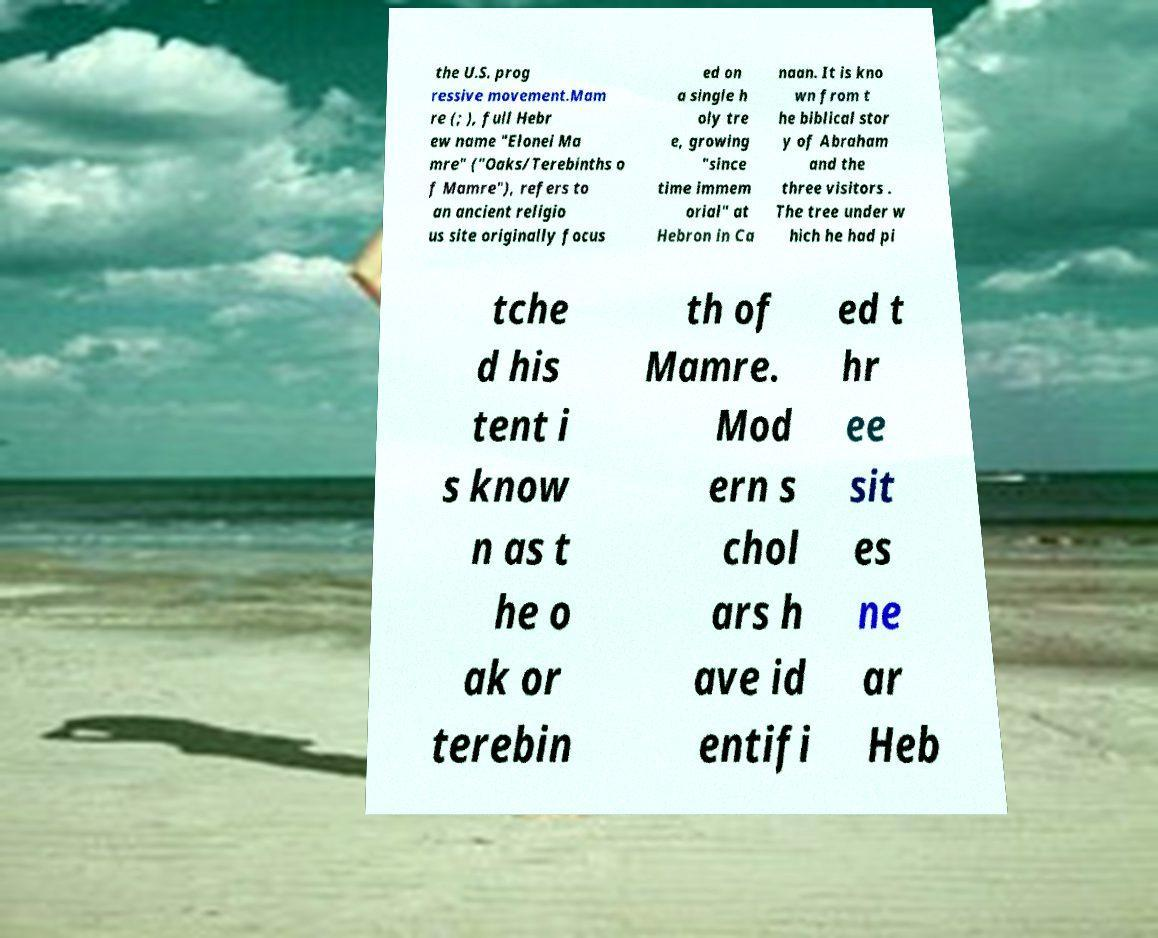What messages or text are displayed in this image? I need them in a readable, typed format. the U.S. prog ressive movement.Mam re (; ), full Hebr ew name "Elonei Ma mre" ("Oaks/Terebinths o f Mamre"), refers to an ancient religio us site originally focus ed on a single h oly tre e, growing "since time immem orial" at Hebron in Ca naan. It is kno wn from t he biblical stor y of Abraham and the three visitors . The tree under w hich he had pi tche d his tent i s know n as t he o ak or terebin th of Mamre. Mod ern s chol ars h ave id entifi ed t hr ee sit es ne ar Heb 